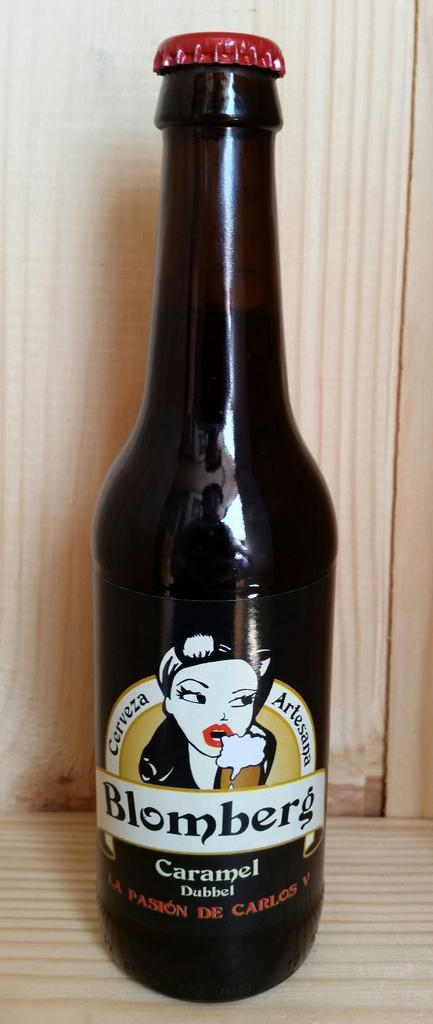<image>
Give a short and clear explanation of the subsequent image. A beer bottle reading Blomberg Caramel sitting on a table. 